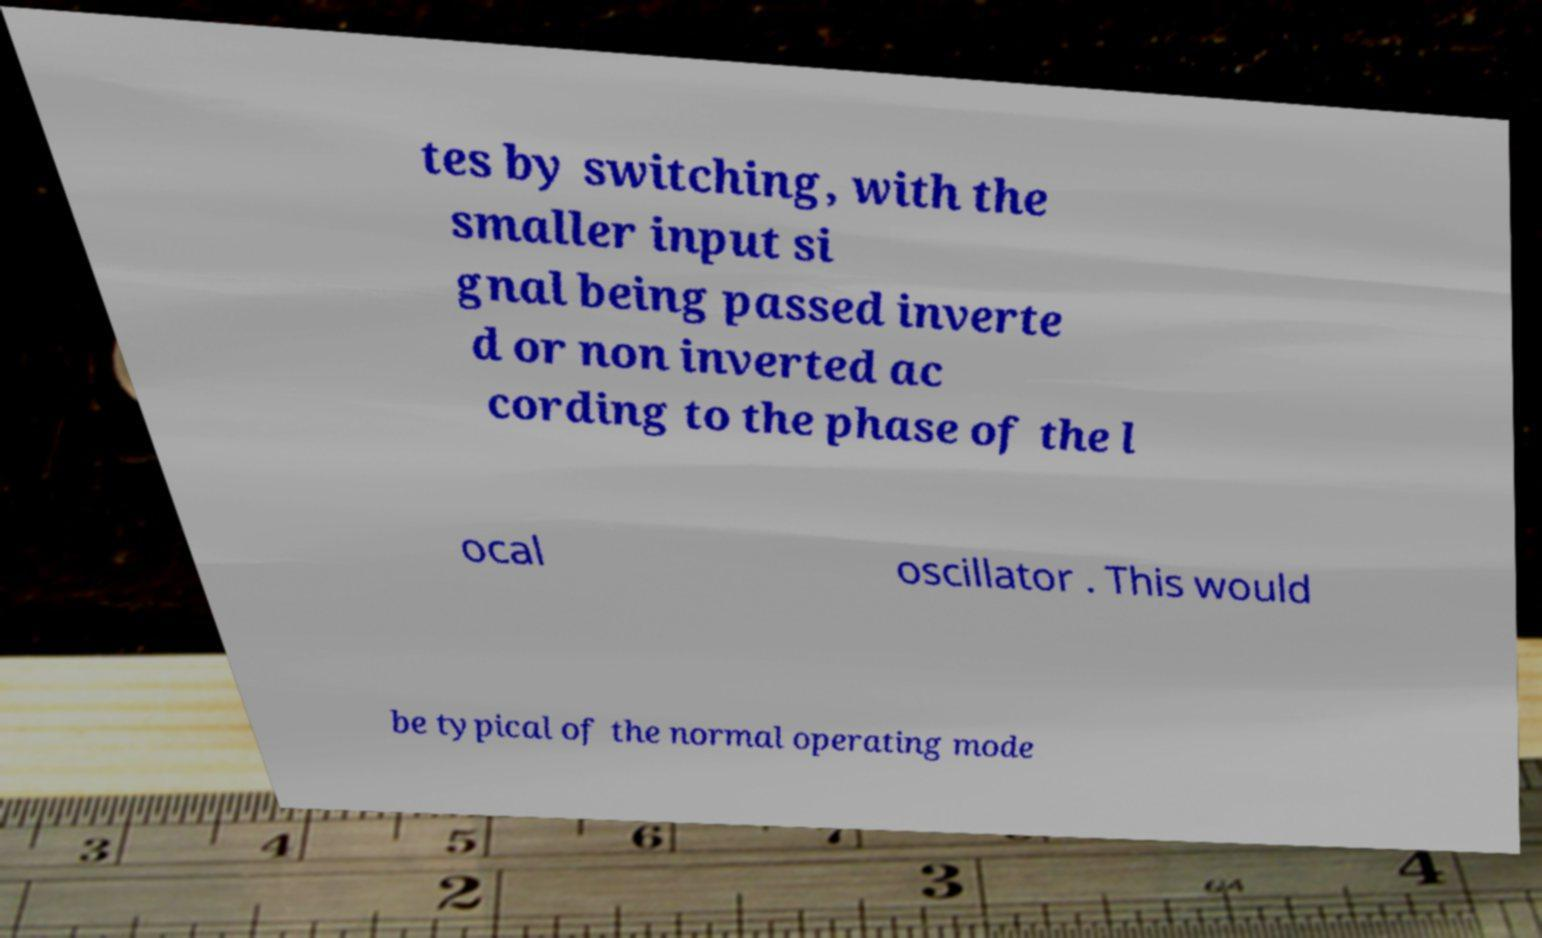Please read and relay the text visible in this image. What does it say? tes by switching, with the smaller input si gnal being passed inverte d or non inverted ac cording to the phase of the l ocal oscillator . This would be typical of the normal operating mode 